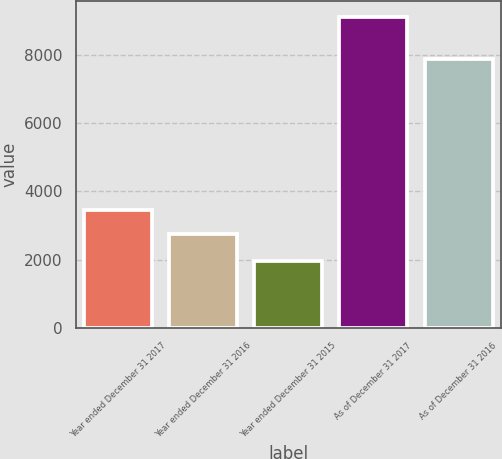Convert chart. <chart><loc_0><loc_0><loc_500><loc_500><bar_chart><fcel>Year ended December 31 2017<fcel>Year ended December 31 2016<fcel>Year ended December 31 2015<fcel>As of December 31 2017<fcel>As of December 31 2016<nl><fcel>3459.1<fcel>2744<fcel>1973<fcel>9124<fcel>7877<nl></chart> 